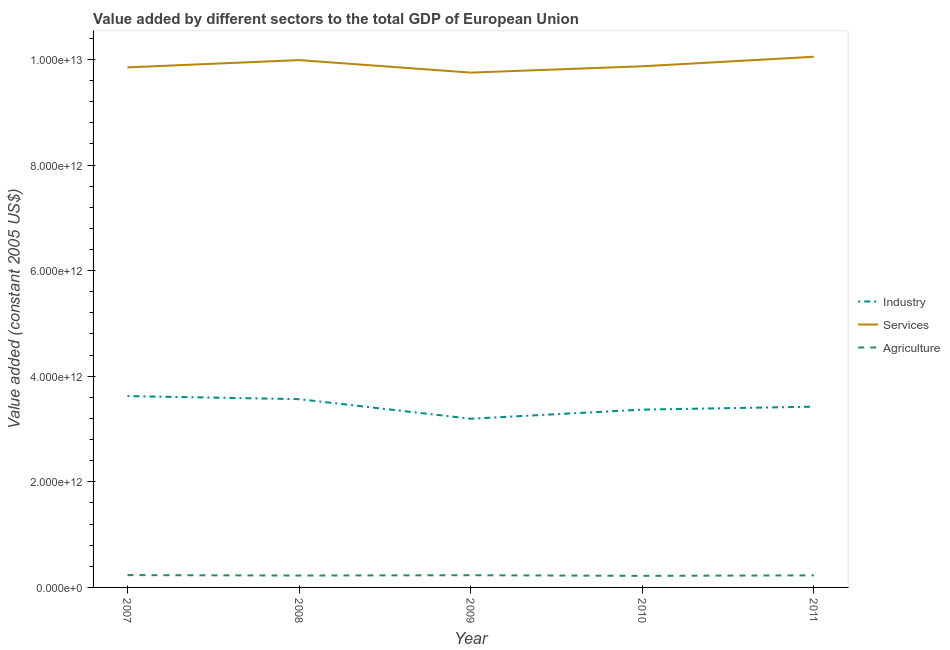Does the line corresponding to value added by industrial sector intersect with the line corresponding to value added by agricultural sector?
Provide a succinct answer. No. What is the value added by industrial sector in 2007?
Provide a short and direct response. 3.62e+12. Across all years, what is the maximum value added by industrial sector?
Offer a terse response. 3.62e+12. Across all years, what is the minimum value added by services?
Provide a succinct answer. 9.75e+12. In which year was the value added by services maximum?
Give a very brief answer. 2011. What is the total value added by industrial sector in the graph?
Offer a terse response. 1.72e+13. What is the difference between the value added by industrial sector in 2008 and that in 2011?
Offer a very short reply. 1.42e+11. What is the difference between the value added by industrial sector in 2007 and the value added by services in 2011?
Your answer should be very brief. -6.43e+12. What is the average value added by agricultural sector per year?
Your response must be concise. 2.28e+11. In the year 2011, what is the difference between the value added by services and value added by agricultural sector?
Your answer should be very brief. 9.82e+12. In how many years, is the value added by services greater than 400000000000 US$?
Your response must be concise. 5. What is the ratio of the value added by agricultural sector in 2010 to that in 2011?
Give a very brief answer. 0.96. Is the difference between the value added by industrial sector in 2007 and 2008 greater than the difference between the value added by services in 2007 and 2008?
Provide a succinct answer. Yes. What is the difference between the highest and the second highest value added by services?
Ensure brevity in your answer.  6.28e+1. What is the difference between the highest and the lowest value added by industrial sector?
Provide a succinct answer. 4.29e+11. In how many years, is the value added by services greater than the average value added by services taken over all years?
Provide a short and direct response. 2. Is it the case that in every year, the sum of the value added by industrial sector and value added by services is greater than the value added by agricultural sector?
Make the answer very short. Yes. Is the value added by agricultural sector strictly greater than the value added by industrial sector over the years?
Provide a short and direct response. No. Is the value added by services strictly less than the value added by agricultural sector over the years?
Offer a terse response. No. How many lines are there?
Keep it short and to the point. 3. How many years are there in the graph?
Provide a short and direct response. 5. What is the difference between two consecutive major ticks on the Y-axis?
Make the answer very short. 2.00e+12. Are the values on the major ticks of Y-axis written in scientific E-notation?
Keep it short and to the point. Yes. Does the graph contain grids?
Offer a very short reply. No. Where does the legend appear in the graph?
Ensure brevity in your answer.  Center right. What is the title of the graph?
Your answer should be very brief. Value added by different sectors to the total GDP of European Union. What is the label or title of the X-axis?
Your answer should be very brief. Year. What is the label or title of the Y-axis?
Provide a short and direct response. Value added (constant 2005 US$). What is the Value added (constant 2005 US$) in Industry in 2007?
Offer a very short reply. 3.62e+12. What is the Value added (constant 2005 US$) of Services in 2007?
Keep it short and to the point. 9.85e+12. What is the Value added (constant 2005 US$) of Agriculture in 2007?
Ensure brevity in your answer.  2.33e+11. What is the Value added (constant 2005 US$) of Industry in 2008?
Offer a very short reply. 3.57e+12. What is the Value added (constant 2005 US$) in Services in 2008?
Your answer should be very brief. 9.99e+12. What is the Value added (constant 2005 US$) of Agriculture in 2008?
Your answer should be very brief. 2.25e+11. What is the Value added (constant 2005 US$) in Industry in 2009?
Make the answer very short. 3.19e+12. What is the Value added (constant 2005 US$) of Services in 2009?
Give a very brief answer. 9.75e+12. What is the Value added (constant 2005 US$) in Agriculture in 2009?
Your answer should be very brief. 2.31e+11. What is the Value added (constant 2005 US$) in Industry in 2010?
Your answer should be very brief. 3.37e+12. What is the Value added (constant 2005 US$) in Services in 2010?
Your answer should be very brief. 9.87e+12. What is the Value added (constant 2005 US$) of Agriculture in 2010?
Keep it short and to the point. 2.20e+11. What is the Value added (constant 2005 US$) in Industry in 2011?
Offer a terse response. 3.42e+12. What is the Value added (constant 2005 US$) of Services in 2011?
Keep it short and to the point. 1.01e+13. What is the Value added (constant 2005 US$) of Agriculture in 2011?
Give a very brief answer. 2.29e+11. Across all years, what is the maximum Value added (constant 2005 US$) of Industry?
Your answer should be very brief. 3.62e+12. Across all years, what is the maximum Value added (constant 2005 US$) of Services?
Offer a terse response. 1.01e+13. Across all years, what is the maximum Value added (constant 2005 US$) in Agriculture?
Make the answer very short. 2.33e+11. Across all years, what is the minimum Value added (constant 2005 US$) in Industry?
Keep it short and to the point. 3.19e+12. Across all years, what is the minimum Value added (constant 2005 US$) in Services?
Ensure brevity in your answer.  9.75e+12. Across all years, what is the minimum Value added (constant 2005 US$) of Agriculture?
Ensure brevity in your answer.  2.20e+11. What is the total Value added (constant 2005 US$) of Industry in the graph?
Provide a succinct answer. 1.72e+13. What is the total Value added (constant 2005 US$) in Services in the graph?
Offer a very short reply. 4.95e+13. What is the total Value added (constant 2005 US$) in Agriculture in the graph?
Your answer should be compact. 1.14e+12. What is the difference between the Value added (constant 2005 US$) in Industry in 2007 and that in 2008?
Your answer should be very brief. 5.77e+1. What is the difference between the Value added (constant 2005 US$) in Services in 2007 and that in 2008?
Give a very brief answer. -1.38e+11. What is the difference between the Value added (constant 2005 US$) in Agriculture in 2007 and that in 2008?
Keep it short and to the point. 8.12e+09. What is the difference between the Value added (constant 2005 US$) in Industry in 2007 and that in 2009?
Your response must be concise. 4.29e+11. What is the difference between the Value added (constant 2005 US$) in Services in 2007 and that in 2009?
Offer a very short reply. 9.87e+1. What is the difference between the Value added (constant 2005 US$) of Agriculture in 2007 and that in 2009?
Keep it short and to the point. 2.23e+09. What is the difference between the Value added (constant 2005 US$) of Industry in 2007 and that in 2010?
Provide a short and direct response. 2.56e+11. What is the difference between the Value added (constant 2005 US$) in Services in 2007 and that in 2010?
Provide a succinct answer. -2.10e+1. What is the difference between the Value added (constant 2005 US$) in Agriculture in 2007 and that in 2010?
Provide a short and direct response. 1.38e+1. What is the difference between the Value added (constant 2005 US$) in Industry in 2007 and that in 2011?
Provide a succinct answer. 2.00e+11. What is the difference between the Value added (constant 2005 US$) of Services in 2007 and that in 2011?
Make the answer very short. -2.01e+11. What is the difference between the Value added (constant 2005 US$) of Agriculture in 2007 and that in 2011?
Give a very brief answer. 4.87e+09. What is the difference between the Value added (constant 2005 US$) in Industry in 2008 and that in 2009?
Make the answer very short. 3.71e+11. What is the difference between the Value added (constant 2005 US$) in Services in 2008 and that in 2009?
Provide a succinct answer. 2.37e+11. What is the difference between the Value added (constant 2005 US$) in Agriculture in 2008 and that in 2009?
Keep it short and to the point. -5.89e+09. What is the difference between the Value added (constant 2005 US$) in Industry in 2008 and that in 2010?
Your response must be concise. 1.98e+11. What is the difference between the Value added (constant 2005 US$) in Services in 2008 and that in 2010?
Your response must be concise. 1.17e+11. What is the difference between the Value added (constant 2005 US$) in Agriculture in 2008 and that in 2010?
Keep it short and to the point. 5.66e+09. What is the difference between the Value added (constant 2005 US$) in Industry in 2008 and that in 2011?
Make the answer very short. 1.42e+11. What is the difference between the Value added (constant 2005 US$) in Services in 2008 and that in 2011?
Offer a very short reply. -6.28e+1. What is the difference between the Value added (constant 2005 US$) of Agriculture in 2008 and that in 2011?
Ensure brevity in your answer.  -3.25e+09. What is the difference between the Value added (constant 2005 US$) in Industry in 2009 and that in 2010?
Make the answer very short. -1.72e+11. What is the difference between the Value added (constant 2005 US$) in Services in 2009 and that in 2010?
Offer a very short reply. -1.20e+11. What is the difference between the Value added (constant 2005 US$) of Agriculture in 2009 and that in 2010?
Your answer should be very brief. 1.15e+1. What is the difference between the Value added (constant 2005 US$) in Industry in 2009 and that in 2011?
Your answer should be very brief. -2.28e+11. What is the difference between the Value added (constant 2005 US$) of Services in 2009 and that in 2011?
Make the answer very short. -3.00e+11. What is the difference between the Value added (constant 2005 US$) in Agriculture in 2009 and that in 2011?
Give a very brief answer. 2.63e+09. What is the difference between the Value added (constant 2005 US$) in Industry in 2010 and that in 2011?
Ensure brevity in your answer.  -5.60e+1. What is the difference between the Value added (constant 2005 US$) in Services in 2010 and that in 2011?
Your answer should be very brief. -1.80e+11. What is the difference between the Value added (constant 2005 US$) in Agriculture in 2010 and that in 2011?
Offer a terse response. -8.91e+09. What is the difference between the Value added (constant 2005 US$) of Industry in 2007 and the Value added (constant 2005 US$) of Services in 2008?
Offer a terse response. -6.36e+12. What is the difference between the Value added (constant 2005 US$) in Industry in 2007 and the Value added (constant 2005 US$) in Agriculture in 2008?
Offer a very short reply. 3.40e+12. What is the difference between the Value added (constant 2005 US$) in Services in 2007 and the Value added (constant 2005 US$) in Agriculture in 2008?
Your answer should be compact. 9.62e+12. What is the difference between the Value added (constant 2005 US$) of Industry in 2007 and the Value added (constant 2005 US$) of Services in 2009?
Ensure brevity in your answer.  -6.13e+12. What is the difference between the Value added (constant 2005 US$) in Industry in 2007 and the Value added (constant 2005 US$) in Agriculture in 2009?
Provide a succinct answer. 3.39e+12. What is the difference between the Value added (constant 2005 US$) in Services in 2007 and the Value added (constant 2005 US$) in Agriculture in 2009?
Offer a terse response. 9.62e+12. What is the difference between the Value added (constant 2005 US$) of Industry in 2007 and the Value added (constant 2005 US$) of Services in 2010?
Your response must be concise. -6.25e+12. What is the difference between the Value added (constant 2005 US$) of Industry in 2007 and the Value added (constant 2005 US$) of Agriculture in 2010?
Give a very brief answer. 3.40e+12. What is the difference between the Value added (constant 2005 US$) in Services in 2007 and the Value added (constant 2005 US$) in Agriculture in 2010?
Offer a very short reply. 9.63e+12. What is the difference between the Value added (constant 2005 US$) of Industry in 2007 and the Value added (constant 2005 US$) of Services in 2011?
Ensure brevity in your answer.  -6.43e+12. What is the difference between the Value added (constant 2005 US$) of Industry in 2007 and the Value added (constant 2005 US$) of Agriculture in 2011?
Keep it short and to the point. 3.40e+12. What is the difference between the Value added (constant 2005 US$) in Services in 2007 and the Value added (constant 2005 US$) in Agriculture in 2011?
Ensure brevity in your answer.  9.62e+12. What is the difference between the Value added (constant 2005 US$) of Industry in 2008 and the Value added (constant 2005 US$) of Services in 2009?
Offer a terse response. -6.18e+12. What is the difference between the Value added (constant 2005 US$) in Industry in 2008 and the Value added (constant 2005 US$) in Agriculture in 2009?
Provide a succinct answer. 3.33e+12. What is the difference between the Value added (constant 2005 US$) in Services in 2008 and the Value added (constant 2005 US$) in Agriculture in 2009?
Give a very brief answer. 9.76e+12. What is the difference between the Value added (constant 2005 US$) of Industry in 2008 and the Value added (constant 2005 US$) of Services in 2010?
Your answer should be compact. -6.30e+12. What is the difference between the Value added (constant 2005 US$) of Industry in 2008 and the Value added (constant 2005 US$) of Agriculture in 2010?
Provide a succinct answer. 3.35e+12. What is the difference between the Value added (constant 2005 US$) in Services in 2008 and the Value added (constant 2005 US$) in Agriculture in 2010?
Offer a very short reply. 9.77e+12. What is the difference between the Value added (constant 2005 US$) in Industry in 2008 and the Value added (constant 2005 US$) in Services in 2011?
Keep it short and to the point. -6.48e+12. What is the difference between the Value added (constant 2005 US$) in Industry in 2008 and the Value added (constant 2005 US$) in Agriculture in 2011?
Keep it short and to the point. 3.34e+12. What is the difference between the Value added (constant 2005 US$) in Services in 2008 and the Value added (constant 2005 US$) in Agriculture in 2011?
Provide a short and direct response. 9.76e+12. What is the difference between the Value added (constant 2005 US$) in Industry in 2009 and the Value added (constant 2005 US$) in Services in 2010?
Provide a succinct answer. -6.68e+12. What is the difference between the Value added (constant 2005 US$) in Industry in 2009 and the Value added (constant 2005 US$) in Agriculture in 2010?
Provide a short and direct response. 2.98e+12. What is the difference between the Value added (constant 2005 US$) of Services in 2009 and the Value added (constant 2005 US$) of Agriculture in 2010?
Make the answer very short. 9.53e+12. What is the difference between the Value added (constant 2005 US$) in Industry in 2009 and the Value added (constant 2005 US$) in Services in 2011?
Offer a terse response. -6.86e+12. What is the difference between the Value added (constant 2005 US$) in Industry in 2009 and the Value added (constant 2005 US$) in Agriculture in 2011?
Provide a succinct answer. 2.97e+12. What is the difference between the Value added (constant 2005 US$) in Services in 2009 and the Value added (constant 2005 US$) in Agriculture in 2011?
Provide a short and direct response. 9.52e+12. What is the difference between the Value added (constant 2005 US$) of Industry in 2010 and the Value added (constant 2005 US$) of Services in 2011?
Give a very brief answer. -6.68e+12. What is the difference between the Value added (constant 2005 US$) in Industry in 2010 and the Value added (constant 2005 US$) in Agriculture in 2011?
Offer a terse response. 3.14e+12. What is the difference between the Value added (constant 2005 US$) in Services in 2010 and the Value added (constant 2005 US$) in Agriculture in 2011?
Provide a short and direct response. 9.64e+12. What is the average Value added (constant 2005 US$) in Industry per year?
Make the answer very short. 3.44e+12. What is the average Value added (constant 2005 US$) of Services per year?
Provide a succinct answer. 9.90e+12. What is the average Value added (constant 2005 US$) of Agriculture per year?
Provide a succinct answer. 2.28e+11. In the year 2007, what is the difference between the Value added (constant 2005 US$) of Industry and Value added (constant 2005 US$) of Services?
Offer a very short reply. -6.23e+12. In the year 2007, what is the difference between the Value added (constant 2005 US$) of Industry and Value added (constant 2005 US$) of Agriculture?
Your answer should be very brief. 3.39e+12. In the year 2007, what is the difference between the Value added (constant 2005 US$) of Services and Value added (constant 2005 US$) of Agriculture?
Ensure brevity in your answer.  9.62e+12. In the year 2008, what is the difference between the Value added (constant 2005 US$) in Industry and Value added (constant 2005 US$) in Services?
Your response must be concise. -6.42e+12. In the year 2008, what is the difference between the Value added (constant 2005 US$) in Industry and Value added (constant 2005 US$) in Agriculture?
Ensure brevity in your answer.  3.34e+12. In the year 2008, what is the difference between the Value added (constant 2005 US$) in Services and Value added (constant 2005 US$) in Agriculture?
Offer a terse response. 9.76e+12. In the year 2009, what is the difference between the Value added (constant 2005 US$) in Industry and Value added (constant 2005 US$) in Services?
Your response must be concise. -6.56e+12. In the year 2009, what is the difference between the Value added (constant 2005 US$) of Industry and Value added (constant 2005 US$) of Agriculture?
Keep it short and to the point. 2.96e+12. In the year 2009, what is the difference between the Value added (constant 2005 US$) in Services and Value added (constant 2005 US$) in Agriculture?
Offer a very short reply. 9.52e+12. In the year 2010, what is the difference between the Value added (constant 2005 US$) of Industry and Value added (constant 2005 US$) of Services?
Offer a terse response. -6.50e+12. In the year 2010, what is the difference between the Value added (constant 2005 US$) of Industry and Value added (constant 2005 US$) of Agriculture?
Provide a short and direct response. 3.15e+12. In the year 2010, what is the difference between the Value added (constant 2005 US$) of Services and Value added (constant 2005 US$) of Agriculture?
Ensure brevity in your answer.  9.65e+12. In the year 2011, what is the difference between the Value added (constant 2005 US$) of Industry and Value added (constant 2005 US$) of Services?
Your answer should be compact. -6.63e+12. In the year 2011, what is the difference between the Value added (constant 2005 US$) of Industry and Value added (constant 2005 US$) of Agriculture?
Make the answer very short. 3.19e+12. In the year 2011, what is the difference between the Value added (constant 2005 US$) of Services and Value added (constant 2005 US$) of Agriculture?
Your response must be concise. 9.82e+12. What is the ratio of the Value added (constant 2005 US$) in Industry in 2007 to that in 2008?
Provide a short and direct response. 1.02. What is the ratio of the Value added (constant 2005 US$) in Services in 2007 to that in 2008?
Your response must be concise. 0.99. What is the ratio of the Value added (constant 2005 US$) of Agriculture in 2007 to that in 2008?
Keep it short and to the point. 1.04. What is the ratio of the Value added (constant 2005 US$) in Industry in 2007 to that in 2009?
Your answer should be compact. 1.13. What is the ratio of the Value added (constant 2005 US$) in Services in 2007 to that in 2009?
Your answer should be very brief. 1.01. What is the ratio of the Value added (constant 2005 US$) of Agriculture in 2007 to that in 2009?
Provide a short and direct response. 1.01. What is the ratio of the Value added (constant 2005 US$) in Industry in 2007 to that in 2010?
Keep it short and to the point. 1.08. What is the ratio of the Value added (constant 2005 US$) in Agriculture in 2007 to that in 2010?
Make the answer very short. 1.06. What is the ratio of the Value added (constant 2005 US$) in Industry in 2007 to that in 2011?
Make the answer very short. 1.06. What is the ratio of the Value added (constant 2005 US$) of Services in 2007 to that in 2011?
Provide a succinct answer. 0.98. What is the ratio of the Value added (constant 2005 US$) of Agriculture in 2007 to that in 2011?
Make the answer very short. 1.02. What is the ratio of the Value added (constant 2005 US$) of Industry in 2008 to that in 2009?
Give a very brief answer. 1.12. What is the ratio of the Value added (constant 2005 US$) of Services in 2008 to that in 2009?
Give a very brief answer. 1.02. What is the ratio of the Value added (constant 2005 US$) of Agriculture in 2008 to that in 2009?
Your answer should be very brief. 0.97. What is the ratio of the Value added (constant 2005 US$) in Industry in 2008 to that in 2010?
Offer a very short reply. 1.06. What is the ratio of the Value added (constant 2005 US$) in Services in 2008 to that in 2010?
Keep it short and to the point. 1.01. What is the ratio of the Value added (constant 2005 US$) of Agriculture in 2008 to that in 2010?
Your answer should be compact. 1.03. What is the ratio of the Value added (constant 2005 US$) in Industry in 2008 to that in 2011?
Your response must be concise. 1.04. What is the ratio of the Value added (constant 2005 US$) in Agriculture in 2008 to that in 2011?
Make the answer very short. 0.99. What is the ratio of the Value added (constant 2005 US$) of Industry in 2009 to that in 2010?
Give a very brief answer. 0.95. What is the ratio of the Value added (constant 2005 US$) of Services in 2009 to that in 2010?
Provide a short and direct response. 0.99. What is the ratio of the Value added (constant 2005 US$) in Agriculture in 2009 to that in 2010?
Offer a very short reply. 1.05. What is the ratio of the Value added (constant 2005 US$) in Industry in 2009 to that in 2011?
Your answer should be compact. 0.93. What is the ratio of the Value added (constant 2005 US$) in Services in 2009 to that in 2011?
Offer a very short reply. 0.97. What is the ratio of the Value added (constant 2005 US$) of Agriculture in 2009 to that in 2011?
Make the answer very short. 1.01. What is the ratio of the Value added (constant 2005 US$) in Industry in 2010 to that in 2011?
Keep it short and to the point. 0.98. What is the ratio of the Value added (constant 2005 US$) in Services in 2010 to that in 2011?
Provide a short and direct response. 0.98. What is the difference between the highest and the second highest Value added (constant 2005 US$) of Industry?
Your response must be concise. 5.77e+1. What is the difference between the highest and the second highest Value added (constant 2005 US$) of Services?
Your answer should be very brief. 6.28e+1. What is the difference between the highest and the second highest Value added (constant 2005 US$) of Agriculture?
Make the answer very short. 2.23e+09. What is the difference between the highest and the lowest Value added (constant 2005 US$) in Industry?
Provide a short and direct response. 4.29e+11. What is the difference between the highest and the lowest Value added (constant 2005 US$) of Services?
Make the answer very short. 3.00e+11. What is the difference between the highest and the lowest Value added (constant 2005 US$) of Agriculture?
Make the answer very short. 1.38e+1. 